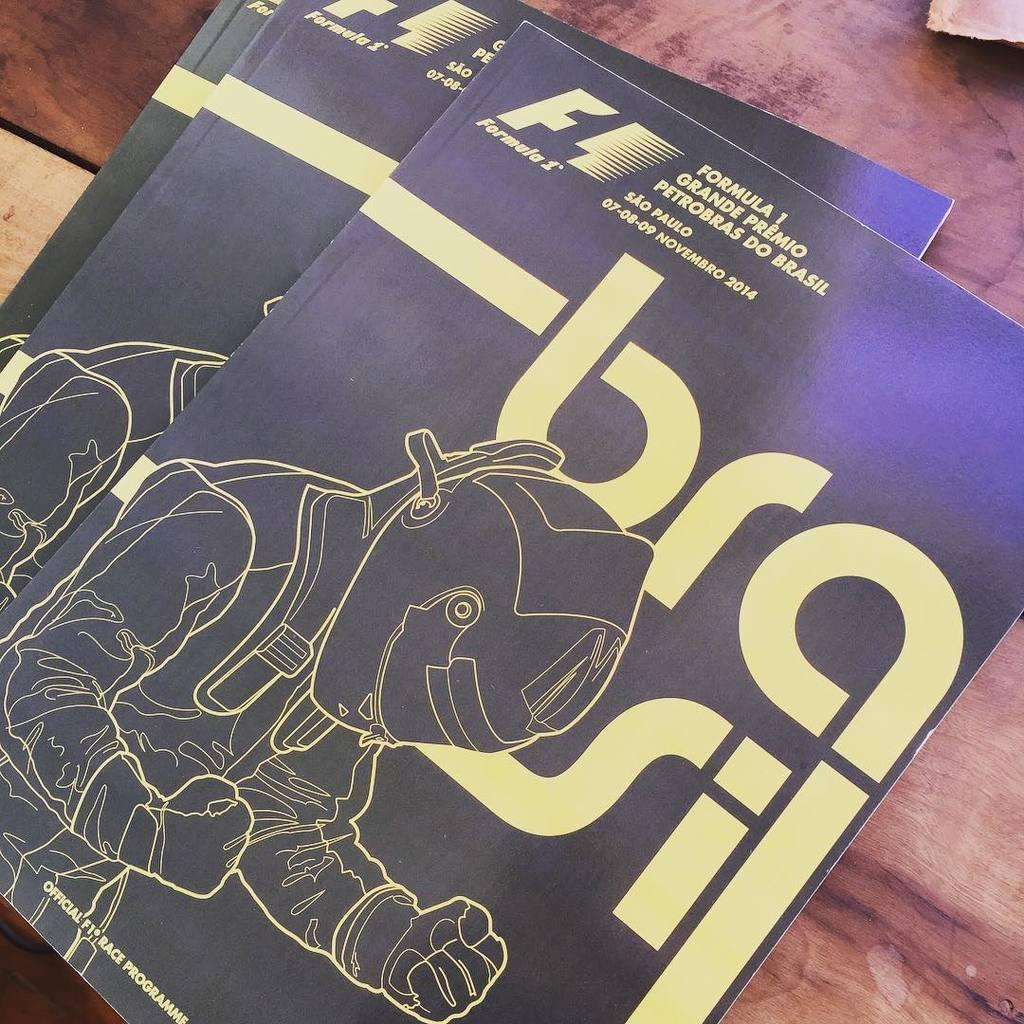Provide a one-sentence caption for the provided image. a person dressed up in a costume and a bra sign behind them. 